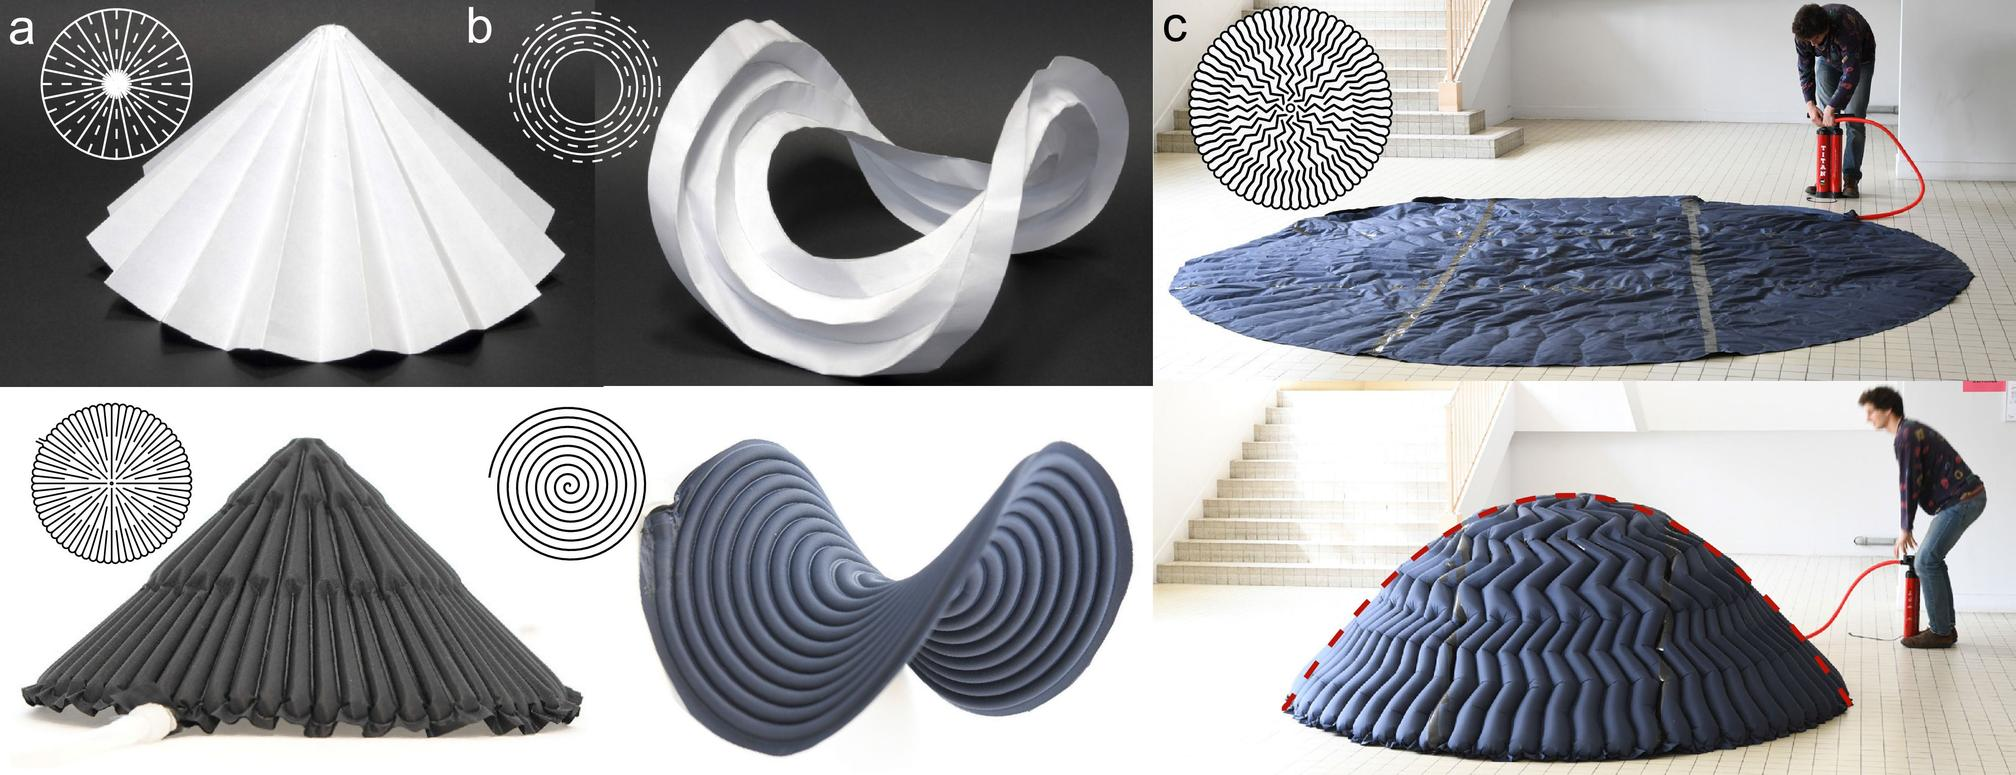What process is being demonstrated in figure (a)? Folding of a flat sheet into a conical shape Cutting of paper into a circular pattern Compression of a circular object into a smaller form Expansion of a cone into a flat sheet Figure (a) shows a flat sheet of paper that has been folded into a conical shape, as evidenced by the radiating fold lines from a central point, similar to the diagram on the left side. Therefore, the correct answer is A. 